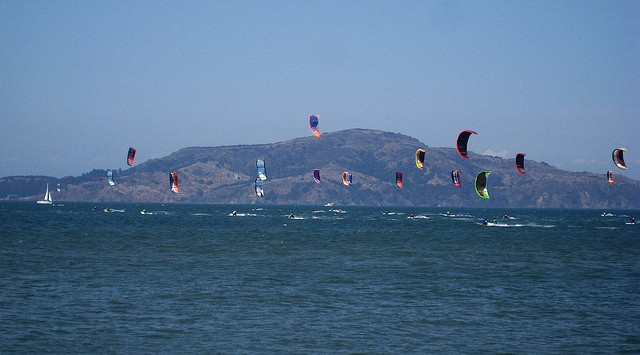Describe the objects in this image and their specific colors. I can see kite in gray and blue tones, kite in gray, black, green, and blue tones, kite in gray, black, maroon, and brown tones, kite in gray, black, maroon, and darkgray tones, and kite in gray, lightpink, blue, navy, and purple tones in this image. 